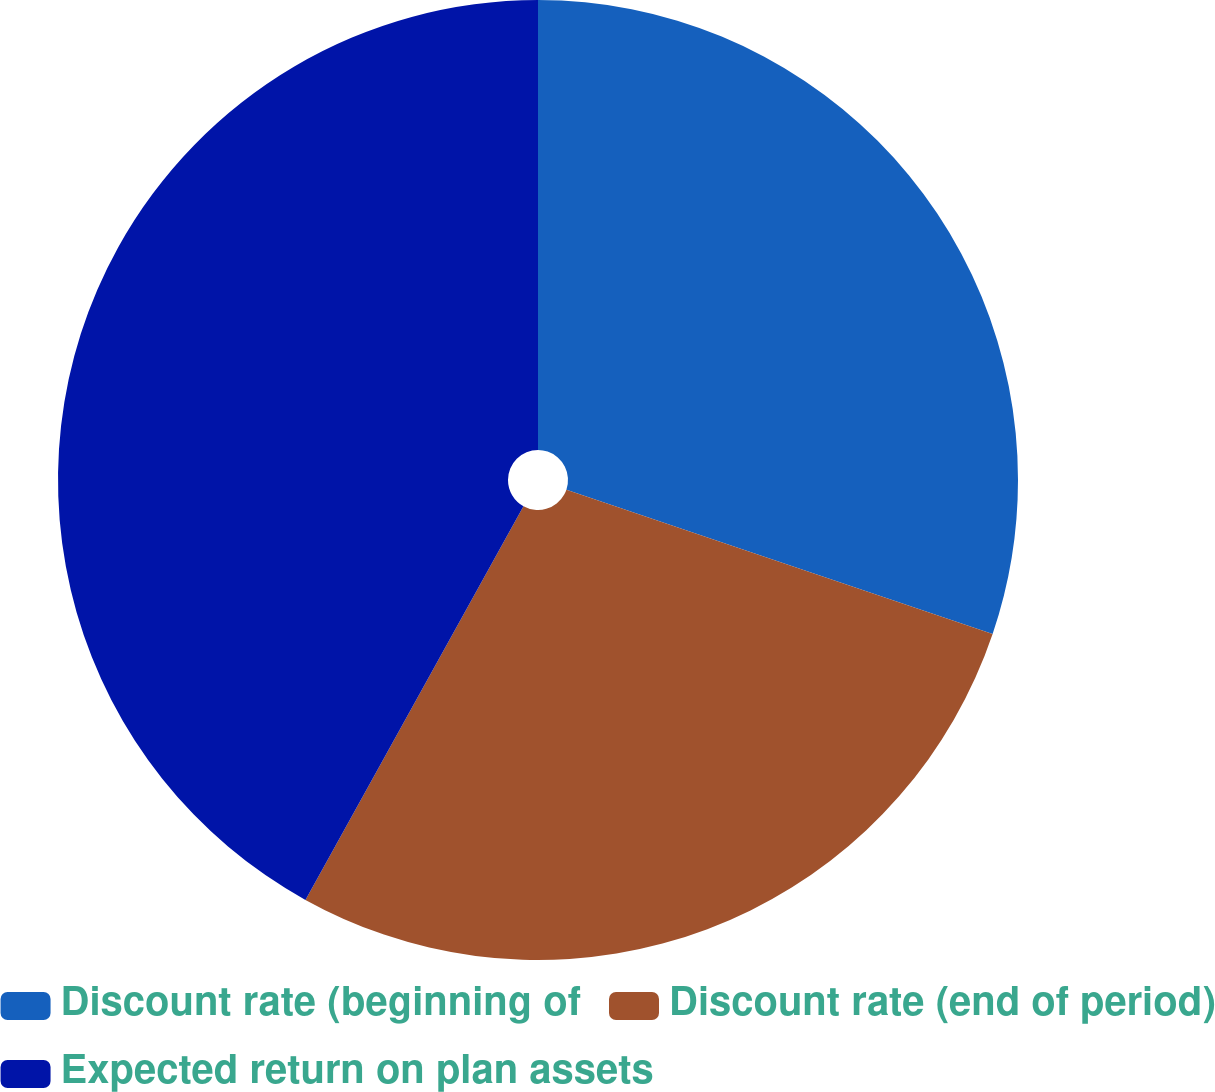<chart> <loc_0><loc_0><loc_500><loc_500><pie_chart><fcel>Discount rate (beginning of<fcel>Discount rate (end of period)<fcel>Expected return on plan assets<nl><fcel>30.2%<fcel>27.85%<fcel>41.95%<nl></chart> 